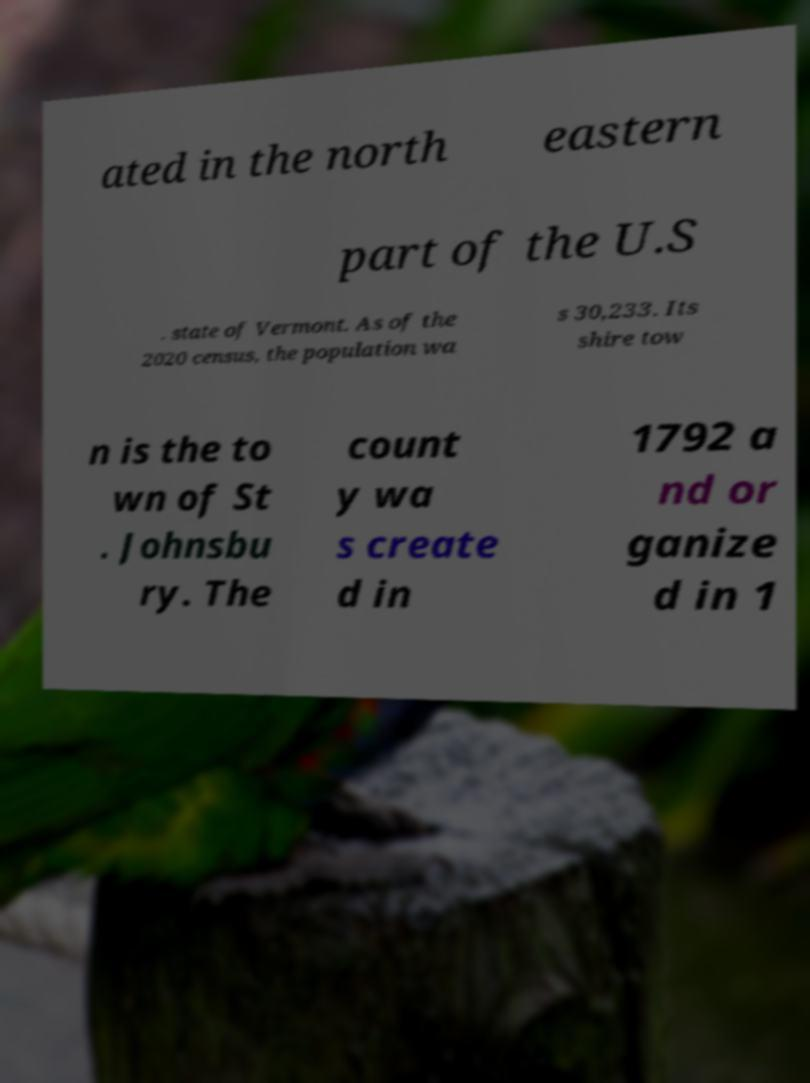Could you assist in decoding the text presented in this image and type it out clearly? ated in the north eastern part of the U.S . state of Vermont. As of the 2020 census, the population wa s 30,233. Its shire tow n is the to wn of St . Johnsbu ry. The count y wa s create d in 1792 a nd or ganize d in 1 